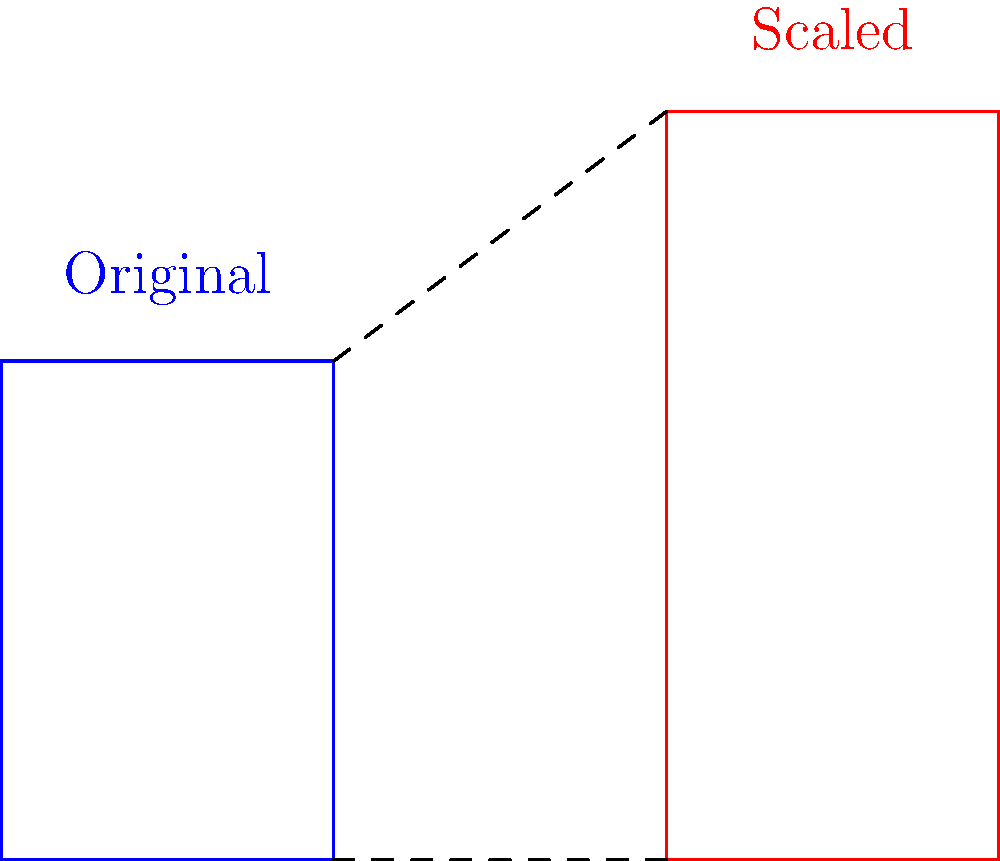During a protest, you notice that your megaphone's effectiveness varies depending on the crowd size. The blue shape represents your original megaphone, while the red shape shows a scaled version. If the height of the original megaphone is 3 units and the scaled version is 4.5 units, what is the scale factor used for this transformation? To find the scale factor, we need to compare the dimensions of the original shape to the scaled shape. Let's follow these steps:

1. Identify the corresponding dimensions:
   - Original height: 3 units
   - Scaled height: 4.5 units

2. Calculate the scale factor using the formula:
   $\text{Scale factor} = \frac{\text{New dimension}}{\text{Original dimension}}$

3. Substitute the values:
   $\text{Scale factor} = \frac{4.5}{3}$

4. Simplify the fraction:
   $\text{Scale factor} = \frac{3 \times 1.5}{3} = 1.5$

Therefore, the scale factor used for this transformation is 1.5, meaning the original megaphone was enlarged by 1.5 times its original size.
Answer: 1.5 